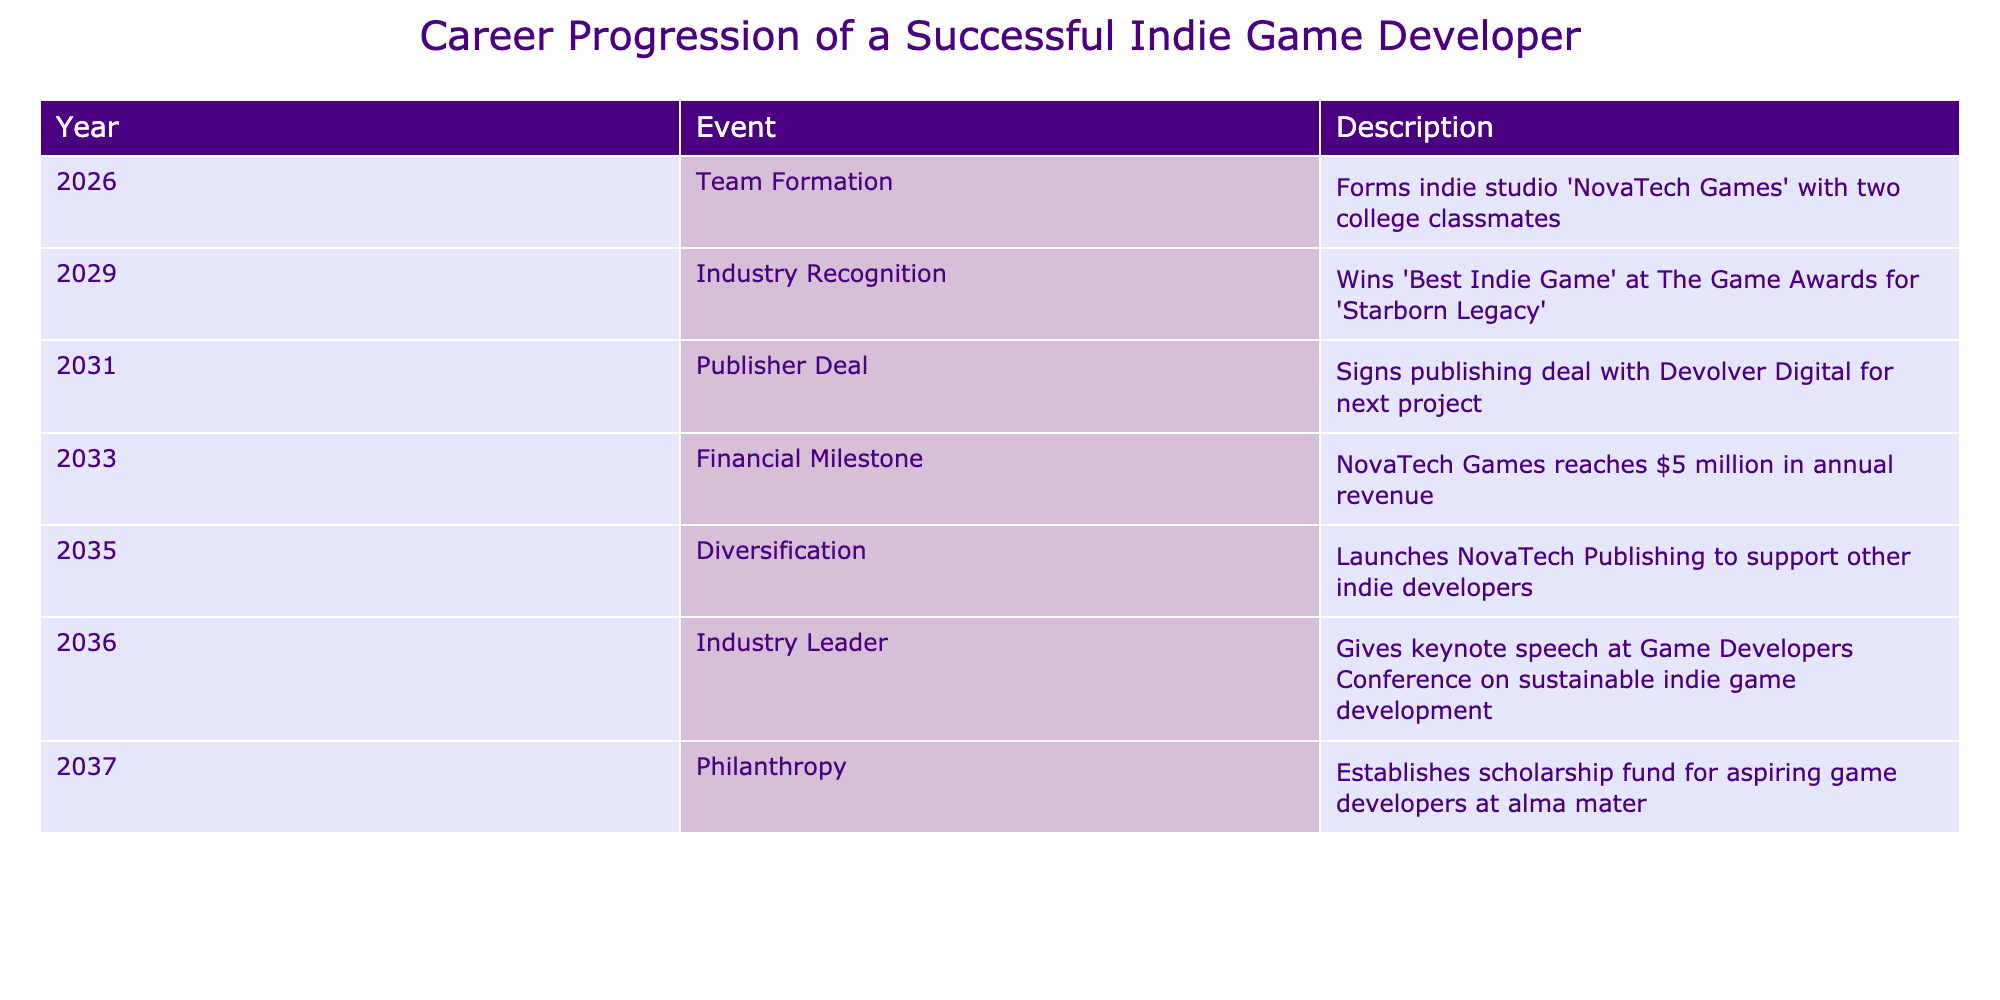What year was NovaTech Games founded? According to the table, the founding year of NovaTech Games is listed under the "Team Formation" event, which occurred in 2026.
Answer: 2026 What event occurred right after NovaTech Games was established? The table shows that the first event is "Team Formation" in 2026, followed by "Industry Recognition" in 2029, indicating that the first significant event after the establishment is the recognition in 2029.
Answer: Industry Recognition How many years passed between the founding of NovaTech Games and the signing of the publisher deal? The founding year is 2026, and the publisher deal occurred in 2031. The difference in years is calculated as 2031 - 2026 = 5.
Answer: 5 Did NovaTech Games achieve financial milestones before they established a scholarship fund? According to the table, "Financial Milestone" is listed in 2033, and "Philanthropy," where the scholarship fund is established, is in 2037. Since 2033 comes before 2037, this statement is true.
Answer: Yes What total number of years did it take for NovaTech Games to reach $5 million in annual revenue after its founding? NovaTech Games reached $5 million in annual revenue in 2033. From its founding in 2026, it took 7 years for them to reach this milestone (2033 - 2026 = 7).
Answer: 7 What are the two main initiatives taken by NovaTech Games in 2035? The milestones listed for 2035 include "Diversification," where NovaTech Games launched NovaTech Publishing to support other indie developers. Thus, the two key initiatives are "Diversification" and the launch of the publishing arm.
Answer: Diversification and NovaTech Publishing launch What is the chronological order of events from founding to philanthropy? The events must be identified and sorted based on the years. From 2026 (Team Formation) to 2029 (Industry Recognition), then 2031 (Publisher Deal), followed by 2033 (Financial Milestone), reaching 2035 (Diversification), and finally 2037 (Philanthropy). The chronological order is therefore: Team Formation, Industry Recognition, Publisher Deal, Financial Milestone, Diversification, Philanthropy.
Answer: Team Formation, Industry Recognition, Publisher Deal, Financial Milestone, Diversification, Philanthropy What percentage of the timeline events are focused on recognition and financial achievements? The timeline lists six events in total. The first two events, "Industry Recognition" and "Financial Milestone," relate to recognition and financial achievement. Therefore, there are 2 such events out of 6 total events. To find the percentage: (2 / 6) * 100 = 33.33%
Answer: 33.33% What significant achievement does NovaTech Games reach by 2033? The significant achievement mentioned in the table is that NovaTech Games reaches $5 million in annual revenue in 2033, showcasing their financial success in the early years after formation.
Answer: $5 million in annual revenue 